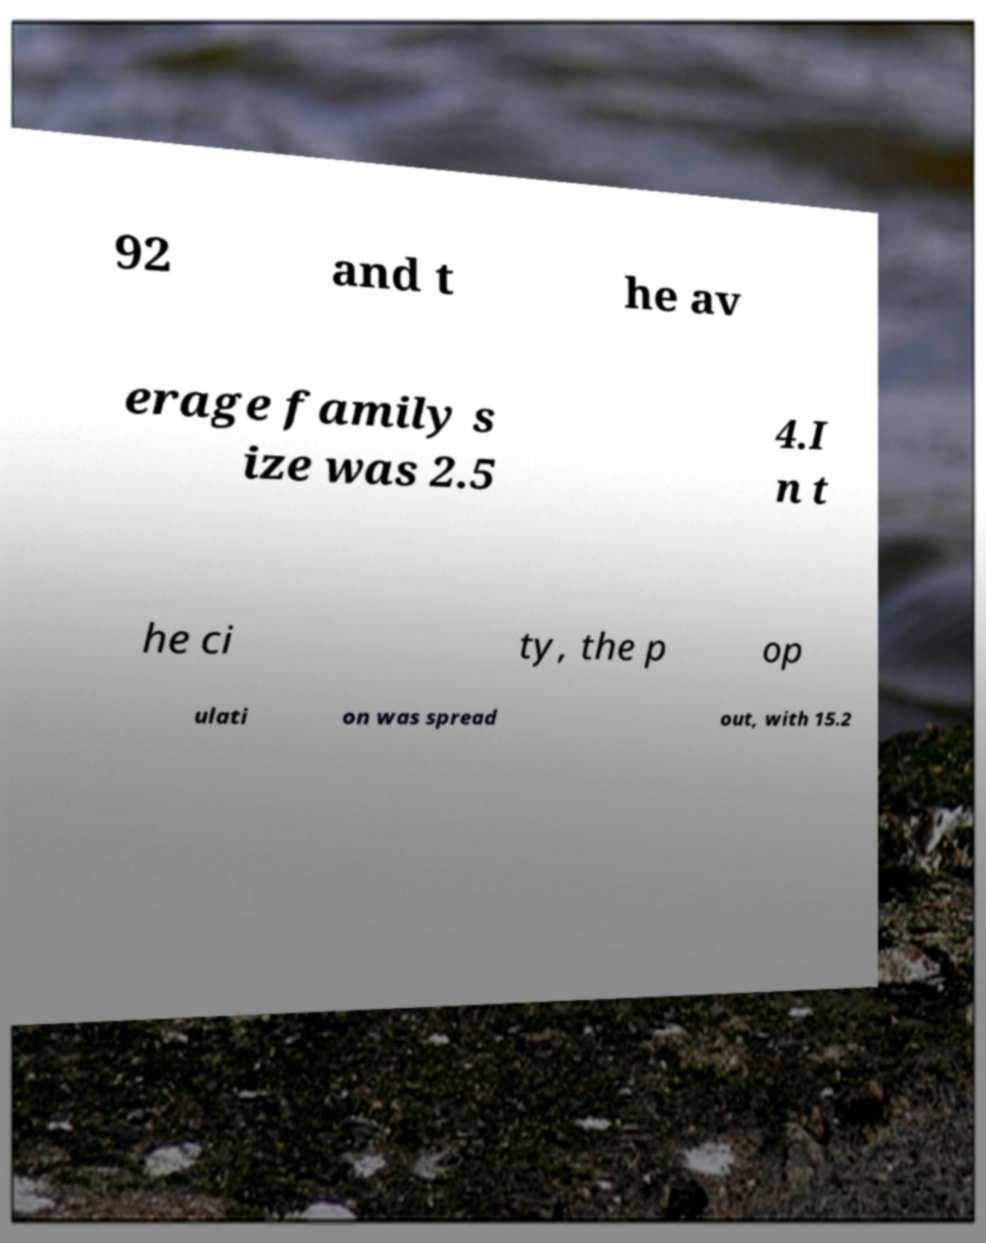I need the written content from this picture converted into text. Can you do that? 92 and t he av erage family s ize was 2.5 4.I n t he ci ty, the p op ulati on was spread out, with 15.2 